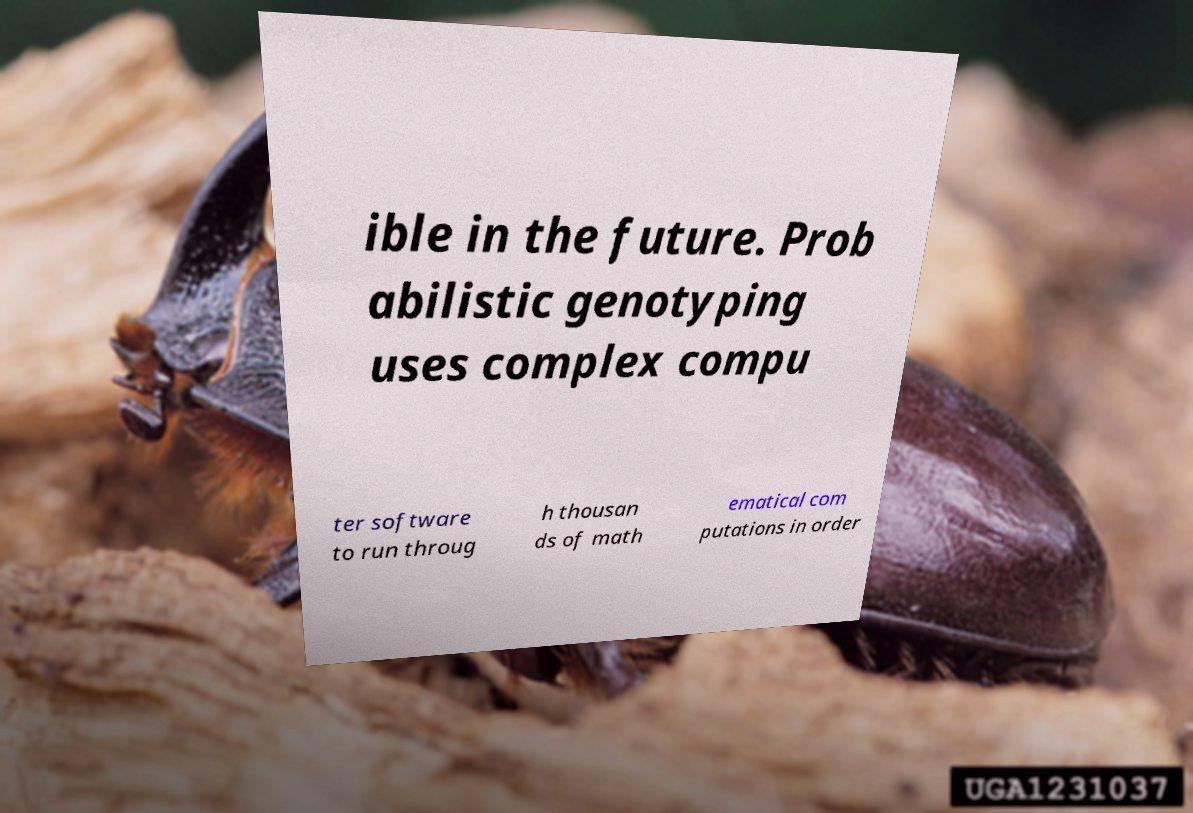For documentation purposes, I need the text within this image transcribed. Could you provide that? ible in the future. Prob abilistic genotyping uses complex compu ter software to run throug h thousan ds of math ematical com putations in order 